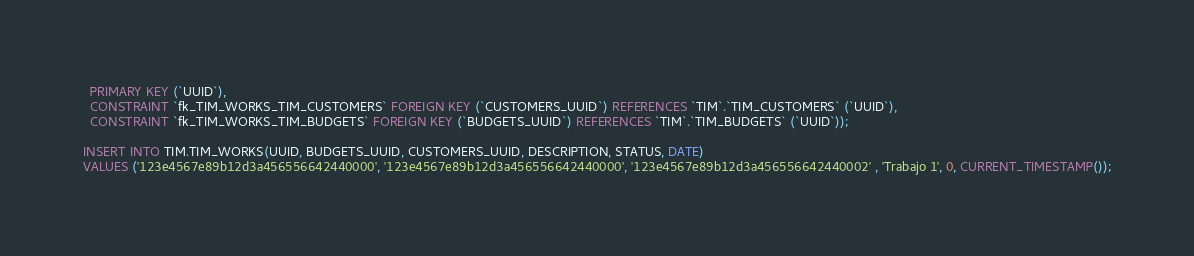Convert code to text. <code><loc_0><loc_0><loc_500><loc_500><_SQL_>  PRIMARY KEY (`UUID`),
  CONSTRAINT `fk_TIM_WORKS_TIM_CUSTOMERS` FOREIGN KEY (`CUSTOMERS_UUID`) REFERENCES `TIM`.`TIM_CUSTOMERS` (`UUID`),
  CONSTRAINT `fk_TIM_WORKS_TIM_BUDGETS` FOREIGN KEY (`BUDGETS_UUID`) REFERENCES `TIM`.`TIM_BUDGETS` (`UUID`));

INSERT INTO TIM.TIM_WORKS(UUID, BUDGETS_UUID, CUSTOMERS_UUID, DESCRIPTION, STATUS, DATE)
VALUES ('123e4567e89b12d3a456556642440000', '123e4567e89b12d3a456556642440000', '123e4567e89b12d3a456556642440002' , 'Trabajo 1', 0, CURRENT_TIMESTAMP());</code> 